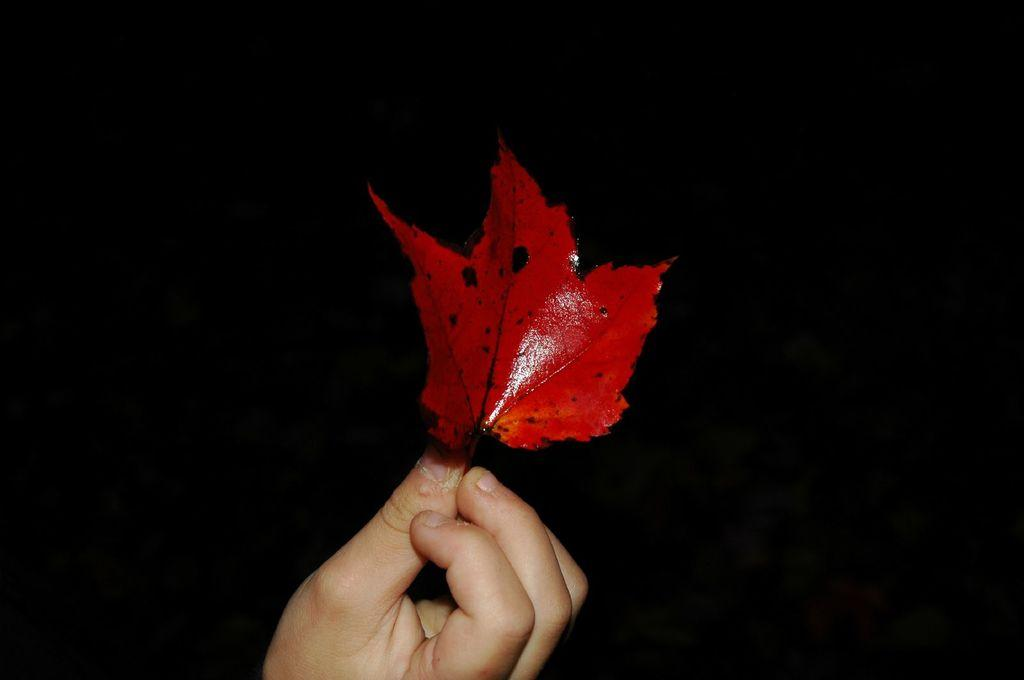What is the main subject of the image? There is a person in the image. What is the person holding in the image? The person is holding a leaf. What can be said about the color of the leaf? The leaf is red in color. What type of leather material can be seen on the sink in the image? There is no sink or leather material present in the image. 